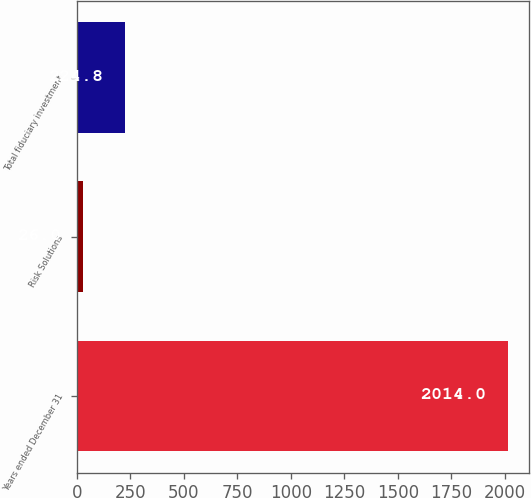<chart> <loc_0><loc_0><loc_500><loc_500><bar_chart><fcel>Years ended December 31<fcel>Risk Solutions<fcel>Total fiduciary investment<nl><fcel>2014<fcel>26<fcel>224.8<nl></chart> 